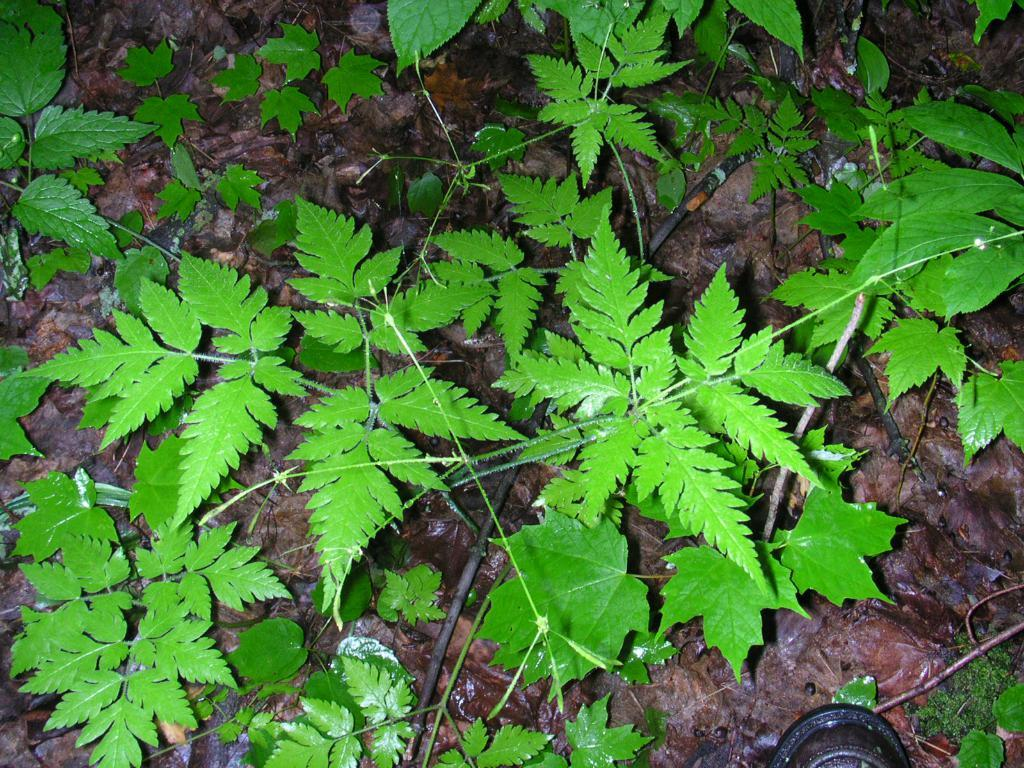What type of vegetation is present in the image? There are green leaves in the image. Can you tell me how many people are swimming in the image? There is no swimming or people present in the image; it only features green leaves. What type of sticks can be seen in the image? There are no sticks present in the image; it only features green leaves. 